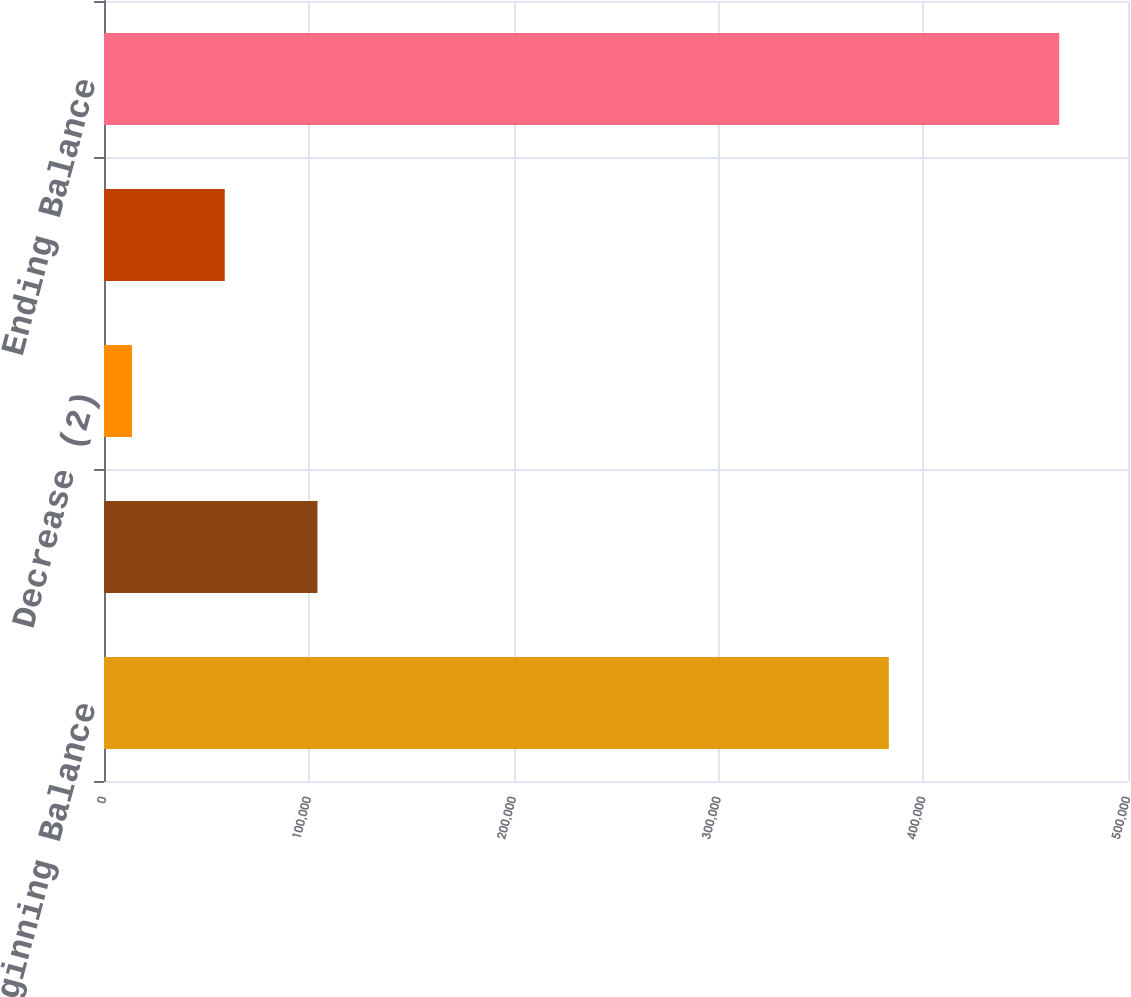Convert chart to OTSL. <chart><loc_0><loc_0><loc_500><loc_500><bar_chart><fcel>Beginning Balance<fcel>Increase (1)<fcel>Decrease (2)<fcel>Other (3)<fcel>Ending Balance<nl><fcel>383221<fcel>104234<fcel>13687<fcel>58960.4<fcel>466421<nl></chart> 